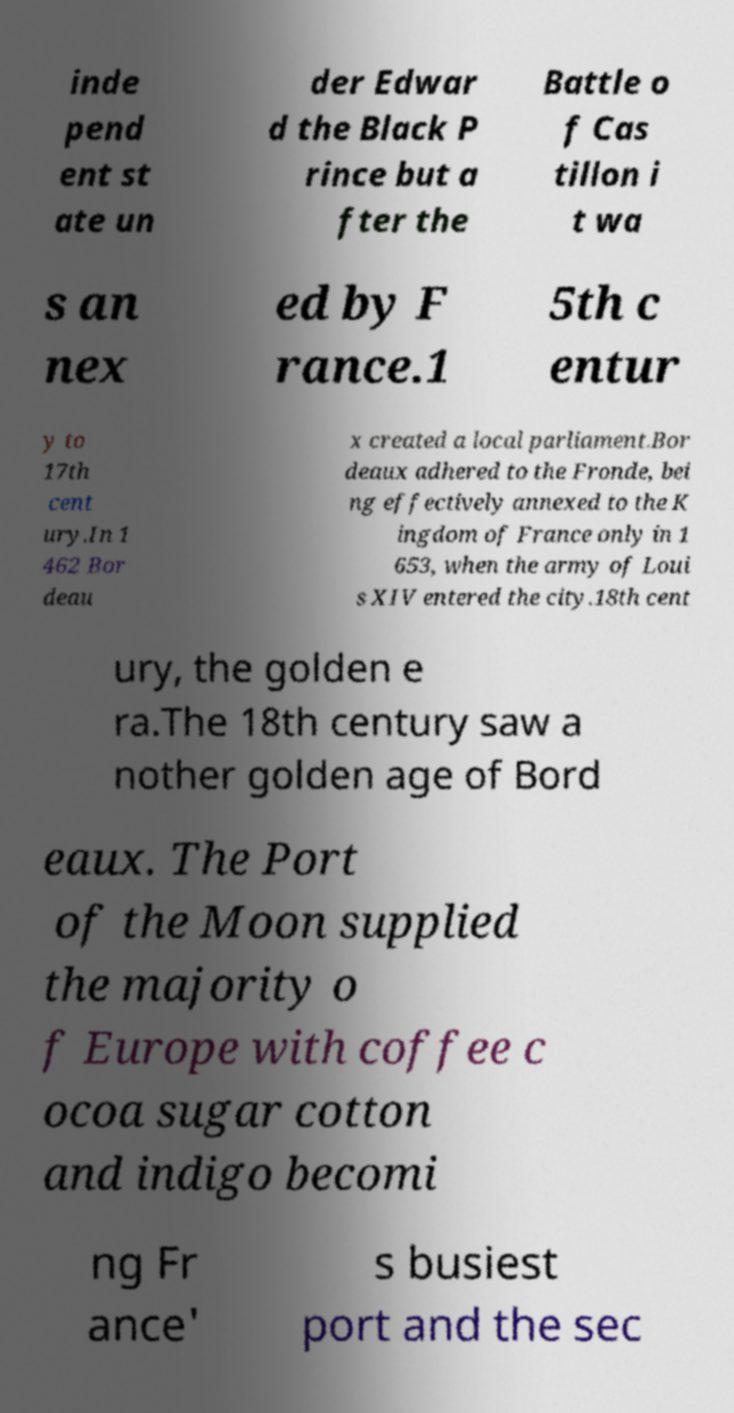Could you assist in decoding the text presented in this image and type it out clearly? inde pend ent st ate un der Edwar d the Black P rince but a fter the Battle o f Cas tillon i t wa s an nex ed by F rance.1 5th c entur y to 17th cent ury.In 1 462 Bor deau x created a local parliament.Bor deaux adhered to the Fronde, bei ng effectively annexed to the K ingdom of France only in 1 653, when the army of Loui s XIV entered the city.18th cent ury, the golden e ra.The 18th century saw a nother golden age of Bord eaux. The Port of the Moon supplied the majority o f Europe with coffee c ocoa sugar cotton and indigo becomi ng Fr ance' s busiest port and the sec 